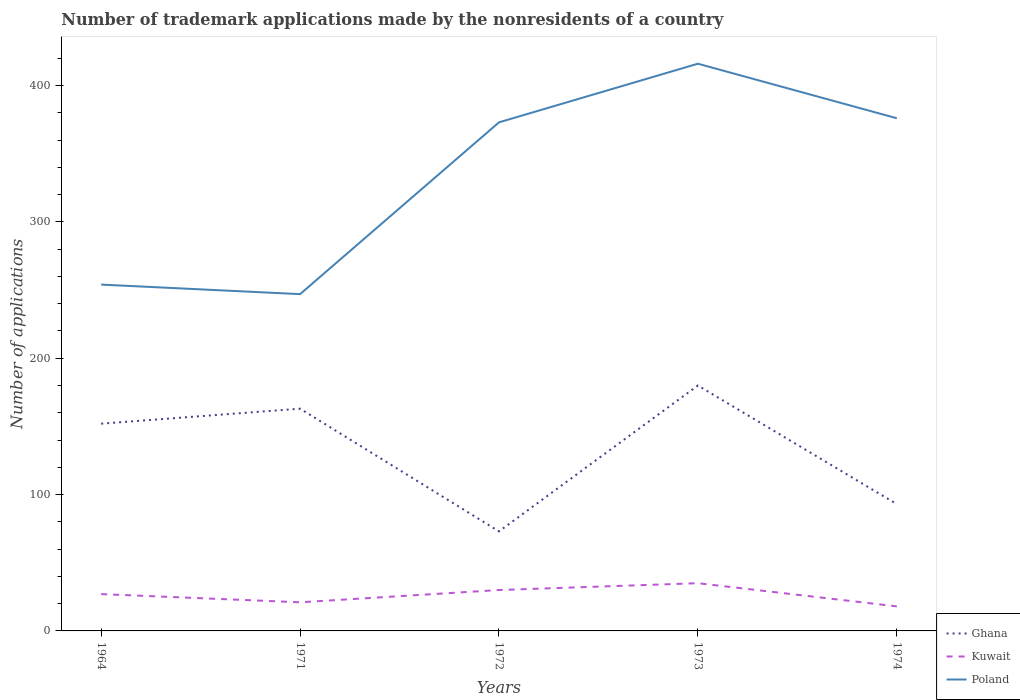How many different coloured lines are there?
Give a very brief answer. 3. Across all years, what is the maximum number of trademark applications made by the nonresidents in Ghana?
Ensure brevity in your answer.  73. In which year was the number of trademark applications made by the nonresidents in Ghana maximum?
Ensure brevity in your answer.  1972. What is the difference between the highest and the second highest number of trademark applications made by the nonresidents in Poland?
Your answer should be very brief. 169. What is the difference between the highest and the lowest number of trademark applications made by the nonresidents in Ghana?
Your response must be concise. 3. Is the number of trademark applications made by the nonresidents in Kuwait strictly greater than the number of trademark applications made by the nonresidents in Ghana over the years?
Make the answer very short. Yes. How many years are there in the graph?
Your response must be concise. 5. Where does the legend appear in the graph?
Your answer should be very brief. Bottom right. How are the legend labels stacked?
Your response must be concise. Vertical. What is the title of the graph?
Your answer should be compact. Number of trademark applications made by the nonresidents of a country. What is the label or title of the Y-axis?
Offer a terse response. Number of applications. What is the Number of applications of Ghana in 1964?
Ensure brevity in your answer.  152. What is the Number of applications in Poland in 1964?
Your answer should be compact. 254. What is the Number of applications of Ghana in 1971?
Give a very brief answer. 163. What is the Number of applications of Kuwait in 1971?
Your answer should be very brief. 21. What is the Number of applications in Poland in 1971?
Provide a succinct answer. 247. What is the Number of applications of Poland in 1972?
Provide a short and direct response. 373. What is the Number of applications in Ghana in 1973?
Keep it short and to the point. 180. What is the Number of applications in Kuwait in 1973?
Your response must be concise. 35. What is the Number of applications in Poland in 1973?
Provide a succinct answer. 416. What is the Number of applications in Ghana in 1974?
Provide a succinct answer. 93. What is the Number of applications in Poland in 1974?
Your answer should be very brief. 376. Across all years, what is the maximum Number of applications in Ghana?
Provide a short and direct response. 180. Across all years, what is the maximum Number of applications in Kuwait?
Your answer should be compact. 35. Across all years, what is the maximum Number of applications in Poland?
Your answer should be compact. 416. Across all years, what is the minimum Number of applications of Poland?
Your response must be concise. 247. What is the total Number of applications of Ghana in the graph?
Your answer should be compact. 661. What is the total Number of applications of Kuwait in the graph?
Make the answer very short. 131. What is the total Number of applications of Poland in the graph?
Make the answer very short. 1666. What is the difference between the Number of applications of Ghana in 1964 and that in 1971?
Your response must be concise. -11. What is the difference between the Number of applications of Ghana in 1964 and that in 1972?
Keep it short and to the point. 79. What is the difference between the Number of applications in Kuwait in 1964 and that in 1972?
Your answer should be compact. -3. What is the difference between the Number of applications of Poland in 1964 and that in 1972?
Give a very brief answer. -119. What is the difference between the Number of applications of Kuwait in 1964 and that in 1973?
Offer a very short reply. -8. What is the difference between the Number of applications in Poland in 1964 and that in 1973?
Offer a terse response. -162. What is the difference between the Number of applications in Ghana in 1964 and that in 1974?
Keep it short and to the point. 59. What is the difference between the Number of applications in Kuwait in 1964 and that in 1974?
Keep it short and to the point. 9. What is the difference between the Number of applications in Poland in 1964 and that in 1974?
Give a very brief answer. -122. What is the difference between the Number of applications of Poland in 1971 and that in 1972?
Give a very brief answer. -126. What is the difference between the Number of applications in Poland in 1971 and that in 1973?
Your response must be concise. -169. What is the difference between the Number of applications in Kuwait in 1971 and that in 1974?
Provide a short and direct response. 3. What is the difference between the Number of applications of Poland in 1971 and that in 1974?
Provide a short and direct response. -129. What is the difference between the Number of applications of Ghana in 1972 and that in 1973?
Provide a succinct answer. -107. What is the difference between the Number of applications of Kuwait in 1972 and that in 1973?
Ensure brevity in your answer.  -5. What is the difference between the Number of applications of Poland in 1972 and that in 1973?
Provide a succinct answer. -43. What is the difference between the Number of applications of Kuwait in 1972 and that in 1974?
Offer a terse response. 12. What is the difference between the Number of applications in Poland in 1972 and that in 1974?
Your answer should be very brief. -3. What is the difference between the Number of applications of Ghana in 1973 and that in 1974?
Provide a succinct answer. 87. What is the difference between the Number of applications in Poland in 1973 and that in 1974?
Provide a succinct answer. 40. What is the difference between the Number of applications of Ghana in 1964 and the Number of applications of Kuwait in 1971?
Your answer should be very brief. 131. What is the difference between the Number of applications of Ghana in 1964 and the Number of applications of Poland in 1971?
Make the answer very short. -95. What is the difference between the Number of applications in Kuwait in 1964 and the Number of applications in Poland in 1971?
Make the answer very short. -220. What is the difference between the Number of applications in Ghana in 1964 and the Number of applications in Kuwait in 1972?
Provide a succinct answer. 122. What is the difference between the Number of applications in Ghana in 1964 and the Number of applications in Poland in 1972?
Make the answer very short. -221. What is the difference between the Number of applications of Kuwait in 1964 and the Number of applications of Poland in 1972?
Your answer should be very brief. -346. What is the difference between the Number of applications in Ghana in 1964 and the Number of applications in Kuwait in 1973?
Make the answer very short. 117. What is the difference between the Number of applications of Ghana in 1964 and the Number of applications of Poland in 1973?
Offer a terse response. -264. What is the difference between the Number of applications in Kuwait in 1964 and the Number of applications in Poland in 1973?
Make the answer very short. -389. What is the difference between the Number of applications of Ghana in 1964 and the Number of applications of Kuwait in 1974?
Provide a short and direct response. 134. What is the difference between the Number of applications of Ghana in 1964 and the Number of applications of Poland in 1974?
Offer a very short reply. -224. What is the difference between the Number of applications of Kuwait in 1964 and the Number of applications of Poland in 1974?
Your answer should be compact. -349. What is the difference between the Number of applications of Ghana in 1971 and the Number of applications of Kuwait in 1972?
Ensure brevity in your answer.  133. What is the difference between the Number of applications of Ghana in 1971 and the Number of applications of Poland in 1972?
Keep it short and to the point. -210. What is the difference between the Number of applications in Kuwait in 1971 and the Number of applications in Poland in 1972?
Your answer should be very brief. -352. What is the difference between the Number of applications in Ghana in 1971 and the Number of applications in Kuwait in 1973?
Provide a succinct answer. 128. What is the difference between the Number of applications of Ghana in 1971 and the Number of applications of Poland in 1973?
Your answer should be very brief. -253. What is the difference between the Number of applications of Kuwait in 1971 and the Number of applications of Poland in 1973?
Provide a short and direct response. -395. What is the difference between the Number of applications in Ghana in 1971 and the Number of applications in Kuwait in 1974?
Your response must be concise. 145. What is the difference between the Number of applications in Ghana in 1971 and the Number of applications in Poland in 1974?
Your answer should be very brief. -213. What is the difference between the Number of applications of Kuwait in 1971 and the Number of applications of Poland in 1974?
Offer a very short reply. -355. What is the difference between the Number of applications in Ghana in 1972 and the Number of applications in Kuwait in 1973?
Make the answer very short. 38. What is the difference between the Number of applications in Ghana in 1972 and the Number of applications in Poland in 1973?
Give a very brief answer. -343. What is the difference between the Number of applications in Kuwait in 1972 and the Number of applications in Poland in 1973?
Keep it short and to the point. -386. What is the difference between the Number of applications of Ghana in 1972 and the Number of applications of Poland in 1974?
Your answer should be compact. -303. What is the difference between the Number of applications of Kuwait in 1972 and the Number of applications of Poland in 1974?
Offer a very short reply. -346. What is the difference between the Number of applications of Ghana in 1973 and the Number of applications of Kuwait in 1974?
Provide a succinct answer. 162. What is the difference between the Number of applications of Ghana in 1973 and the Number of applications of Poland in 1974?
Your response must be concise. -196. What is the difference between the Number of applications of Kuwait in 1973 and the Number of applications of Poland in 1974?
Your answer should be compact. -341. What is the average Number of applications in Ghana per year?
Your answer should be very brief. 132.2. What is the average Number of applications in Kuwait per year?
Your answer should be very brief. 26.2. What is the average Number of applications of Poland per year?
Provide a short and direct response. 333.2. In the year 1964, what is the difference between the Number of applications in Ghana and Number of applications in Kuwait?
Provide a succinct answer. 125. In the year 1964, what is the difference between the Number of applications in Ghana and Number of applications in Poland?
Your answer should be compact. -102. In the year 1964, what is the difference between the Number of applications of Kuwait and Number of applications of Poland?
Keep it short and to the point. -227. In the year 1971, what is the difference between the Number of applications of Ghana and Number of applications of Kuwait?
Give a very brief answer. 142. In the year 1971, what is the difference between the Number of applications of Ghana and Number of applications of Poland?
Provide a succinct answer. -84. In the year 1971, what is the difference between the Number of applications in Kuwait and Number of applications in Poland?
Offer a very short reply. -226. In the year 1972, what is the difference between the Number of applications in Ghana and Number of applications in Poland?
Your answer should be compact. -300. In the year 1972, what is the difference between the Number of applications of Kuwait and Number of applications of Poland?
Provide a short and direct response. -343. In the year 1973, what is the difference between the Number of applications in Ghana and Number of applications in Kuwait?
Give a very brief answer. 145. In the year 1973, what is the difference between the Number of applications of Ghana and Number of applications of Poland?
Your answer should be very brief. -236. In the year 1973, what is the difference between the Number of applications in Kuwait and Number of applications in Poland?
Your response must be concise. -381. In the year 1974, what is the difference between the Number of applications of Ghana and Number of applications of Kuwait?
Offer a very short reply. 75. In the year 1974, what is the difference between the Number of applications of Ghana and Number of applications of Poland?
Your response must be concise. -283. In the year 1974, what is the difference between the Number of applications of Kuwait and Number of applications of Poland?
Your response must be concise. -358. What is the ratio of the Number of applications of Ghana in 1964 to that in 1971?
Give a very brief answer. 0.93. What is the ratio of the Number of applications in Kuwait in 1964 to that in 1971?
Your answer should be very brief. 1.29. What is the ratio of the Number of applications of Poland in 1964 to that in 1971?
Your response must be concise. 1.03. What is the ratio of the Number of applications in Ghana in 1964 to that in 1972?
Keep it short and to the point. 2.08. What is the ratio of the Number of applications in Poland in 1964 to that in 1972?
Provide a succinct answer. 0.68. What is the ratio of the Number of applications in Ghana in 1964 to that in 1973?
Provide a succinct answer. 0.84. What is the ratio of the Number of applications in Kuwait in 1964 to that in 1973?
Offer a very short reply. 0.77. What is the ratio of the Number of applications of Poland in 1964 to that in 1973?
Your response must be concise. 0.61. What is the ratio of the Number of applications of Ghana in 1964 to that in 1974?
Make the answer very short. 1.63. What is the ratio of the Number of applications in Poland in 1964 to that in 1974?
Your response must be concise. 0.68. What is the ratio of the Number of applications in Ghana in 1971 to that in 1972?
Provide a succinct answer. 2.23. What is the ratio of the Number of applications in Kuwait in 1971 to that in 1972?
Offer a very short reply. 0.7. What is the ratio of the Number of applications in Poland in 1971 to that in 1972?
Offer a terse response. 0.66. What is the ratio of the Number of applications in Ghana in 1971 to that in 1973?
Your answer should be very brief. 0.91. What is the ratio of the Number of applications in Kuwait in 1971 to that in 1973?
Provide a succinct answer. 0.6. What is the ratio of the Number of applications in Poland in 1971 to that in 1973?
Offer a terse response. 0.59. What is the ratio of the Number of applications in Ghana in 1971 to that in 1974?
Ensure brevity in your answer.  1.75. What is the ratio of the Number of applications in Kuwait in 1971 to that in 1974?
Your answer should be very brief. 1.17. What is the ratio of the Number of applications in Poland in 1971 to that in 1974?
Keep it short and to the point. 0.66. What is the ratio of the Number of applications of Ghana in 1972 to that in 1973?
Provide a succinct answer. 0.41. What is the ratio of the Number of applications of Kuwait in 1972 to that in 1973?
Your answer should be very brief. 0.86. What is the ratio of the Number of applications of Poland in 1972 to that in 1973?
Your response must be concise. 0.9. What is the ratio of the Number of applications in Ghana in 1972 to that in 1974?
Your answer should be compact. 0.78. What is the ratio of the Number of applications of Poland in 1972 to that in 1974?
Your answer should be very brief. 0.99. What is the ratio of the Number of applications of Ghana in 1973 to that in 1974?
Make the answer very short. 1.94. What is the ratio of the Number of applications in Kuwait in 1973 to that in 1974?
Your answer should be compact. 1.94. What is the ratio of the Number of applications in Poland in 1973 to that in 1974?
Ensure brevity in your answer.  1.11. What is the difference between the highest and the second highest Number of applications of Ghana?
Give a very brief answer. 17. What is the difference between the highest and the second highest Number of applications in Kuwait?
Give a very brief answer. 5. What is the difference between the highest and the lowest Number of applications of Ghana?
Provide a succinct answer. 107. What is the difference between the highest and the lowest Number of applications in Poland?
Make the answer very short. 169. 